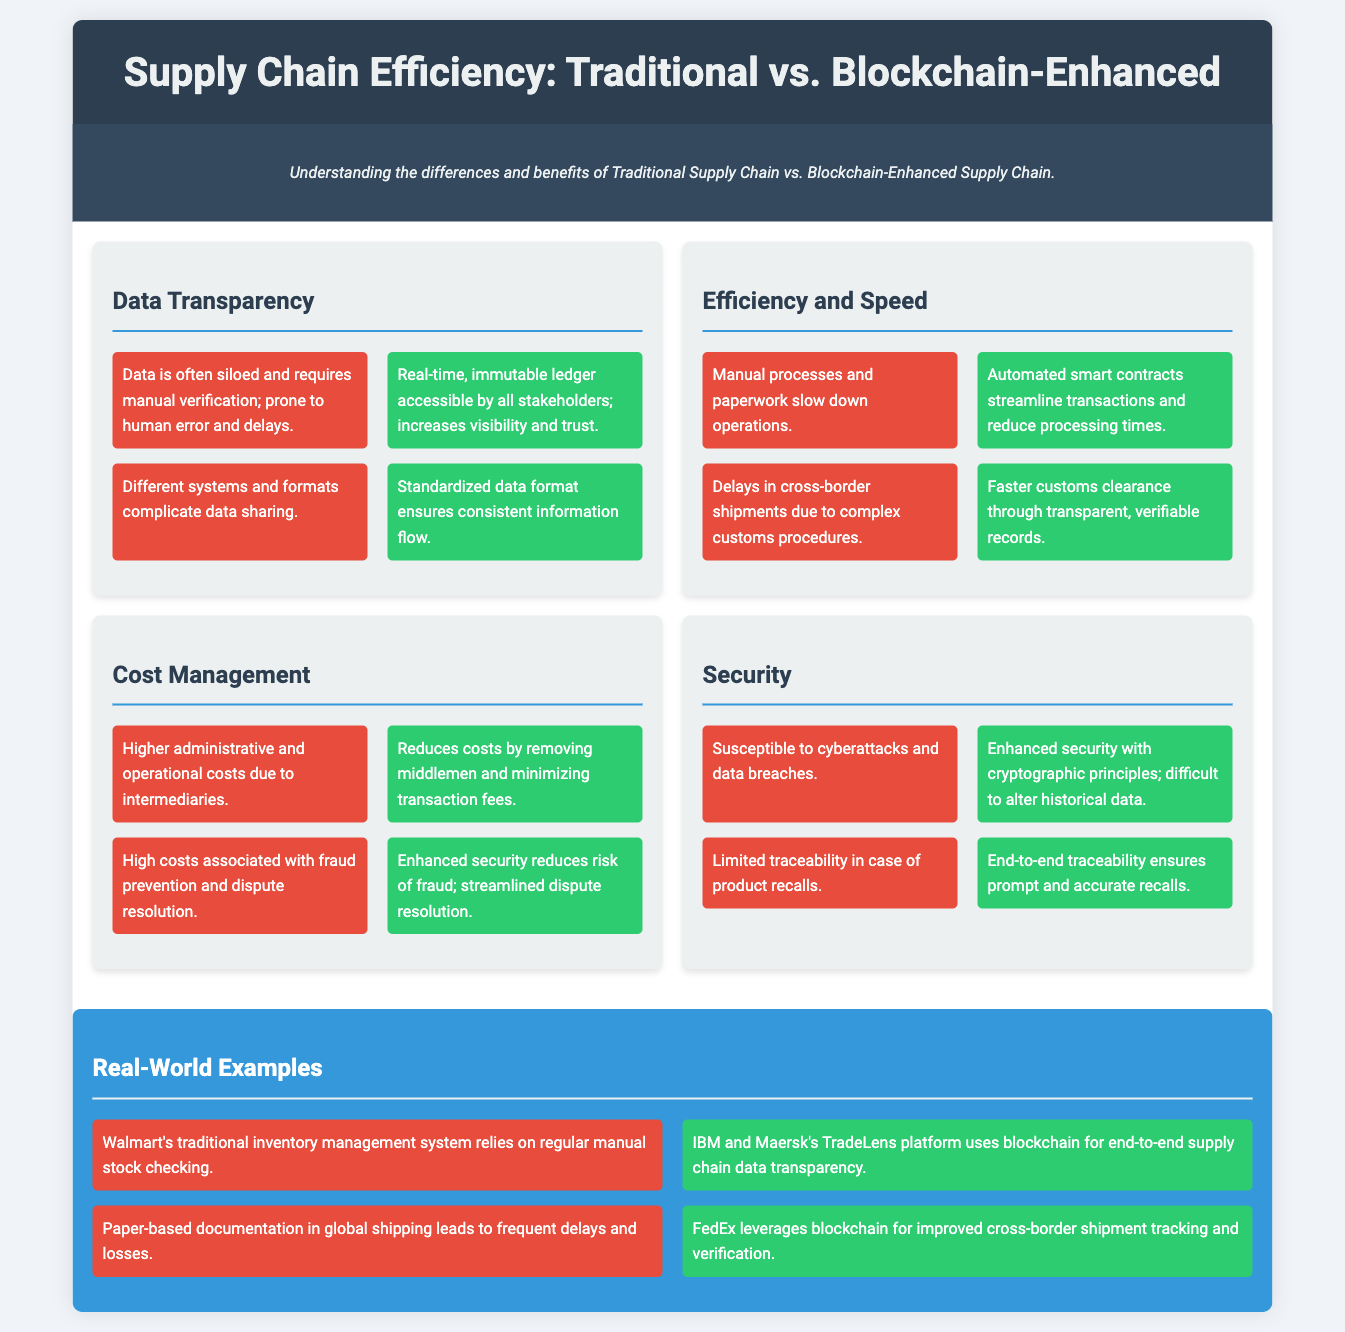What is one key advantage of blockchain in data transparency? The document states that blockchain provides real-time, immutable ledger accessible by all stakeholders, which increases visibility and trust.
Answer: Real-time, immutable ledger What affects operational efficiency in traditional supply chains? According to the document, manual processes and paperwork slow down operations, impacting overall efficiency.
Answer: Manual processes and paperwork How does blockchain improve customs clearance? The infographic indicates that blockchain leads to faster customs clearance through transparent, verifiable records.
Answer: Faster customs clearance What is a significant cost reduction factor of blockchain? The document mentions that blockchain reduces costs by removing middlemen and minimizing transaction fees.
Answer: Removing middlemen What is a major security benefit of blockchain over traditional methods? The infographic highlights that blockchain has enhanced security with cryptographic principles and is difficult to alter historical data compared to traditional methods.
Answer: Enhanced security What example is given for a traditional inventory management system? The document cites Walmart's traditional inventory management system, which relies on regular manual stock checking.
Answer: Walmart's traditional inventory management system Which company utilizes blockchain for improved shipment tracking? The document states that FedEx leverages blockchain for improved cross-border shipment tracking and verification.
Answer: FedEx What condition does traditional supply chains face regarding data? The infographic outlines that data in traditional supply chains is often siloed and requires manual verification, which is prone to human error and delays.
Answer: Data is often siloed What enhances product recall processes in blockchain? The document explains that blockchain provides end-to-end traceability, ensuring prompt and accurate recalls.
Answer: End-to-end traceability 